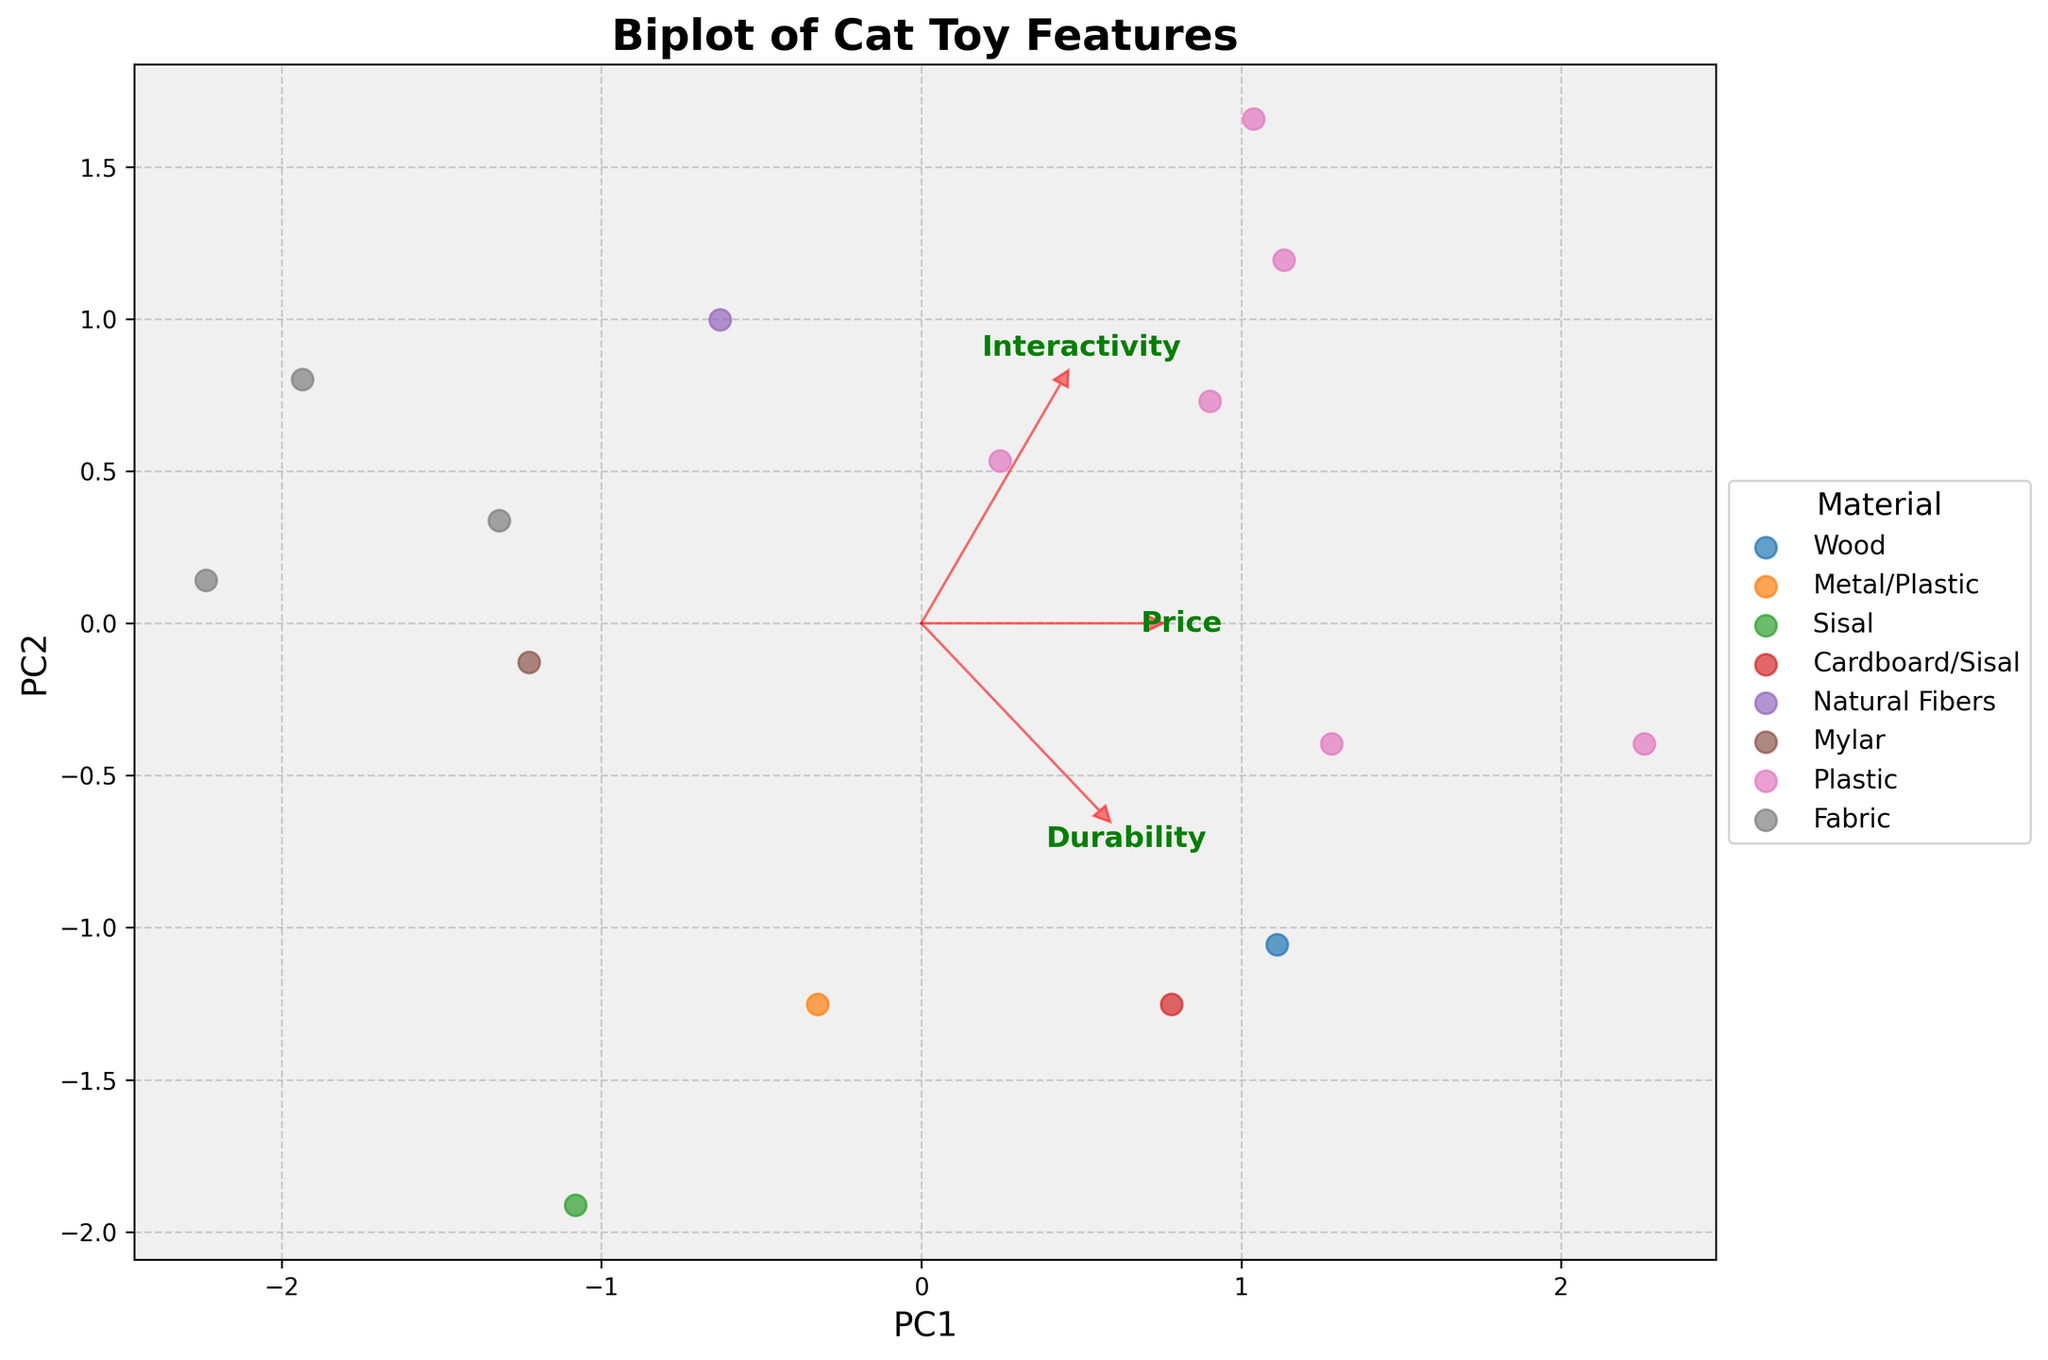What is the title of this plot? The title is displayed prominently at the top of the figure.
Answer: Biplot of Cat Toy Features What does the X-axis represent in this figure? The label for the X-axis is given at the bottom of the plot.
Answer: PC1 Which material has the most diverse distribution among the cat toys? Observe how spread out the points are for each material.
Answer: Plastic How are the features 'Durability' and 'Interactivity' represented on this biplot? These features are represented by red arrows originating from the center. The direction and length of the arrows indicate how much each feature contributes to the principal components.
Answer: Red arrows Which material shows the highest interactivity according to the plot? Look at the points that are farthest in the direction of the 'Interactivity' arrow.
Answer: Plastic Are any toys made with 'Natural Fibers' located closer to 'PC2' than 'PC1'? Identify the points representing 'Natural Fibers' and determine which principal component they align more closely with based on the axes.
Answer: No How does the price of 'Plastic' toys compare to those made of 'Fabric' based on their positions? Observe the direction of the 'Price' arrow and compare the positions of 'Plastic' and 'Fabric' points relative to this direction.
Answer: Plastic toys tend to be higher priced Which toy materials are clustered near the origin of the plot, and what does this indicate? Check which material points are closest to the center (origin) of the biplot where both PC1 and PC2 are minimal.
Answer: Natural Fibers, Fabric, Mylar; this indicates lower variability in features for these materials Between 'Sisal' and 'Wood,' which material's toys have higher 'Durability' based on the plot? Look at the positions of 'Sisal' and 'Wood' materials relative to the 'Durability' arrow direction.
Answer: Wood How does the interactivity of the 'Electronic Moving Mouse' compare to other toys? Identify the point representing the 'Electronic Moving Mouse' and see its position along the 'Interactivity' arrow.
Answer: It has high interactivity 